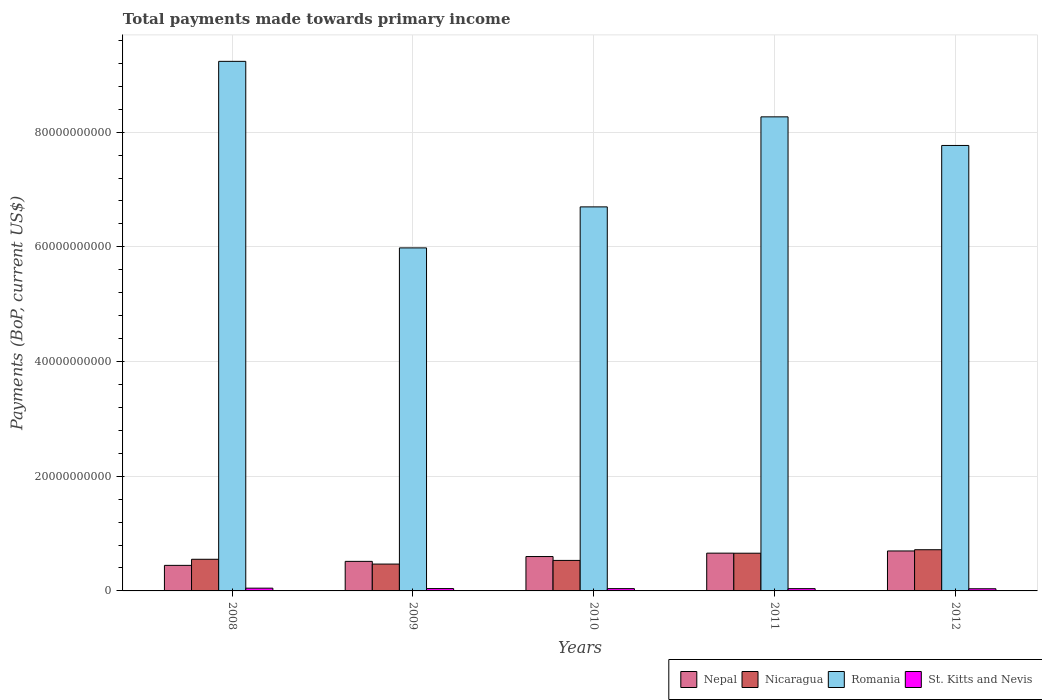How many groups of bars are there?
Your response must be concise. 5. Are the number of bars per tick equal to the number of legend labels?
Your response must be concise. Yes. Are the number of bars on each tick of the X-axis equal?
Make the answer very short. Yes. How many bars are there on the 2nd tick from the left?
Your response must be concise. 4. What is the label of the 2nd group of bars from the left?
Ensure brevity in your answer.  2009. What is the total payments made towards primary income in Nepal in 2008?
Your response must be concise. 4.46e+09. Across all years, what is the maximum total payments made towards primary income in St. Kitts and Nevis?
Make the answer very short. 4.81e+08. Across all years, what is the minimum total payments made towards primary income in Nicaragua?
Make the answer very short. 4.68e+09. In which year was the total payments made towards primary income in Nicaragua minimum?
Your answer should be very brief. 2009. What is the total total payments made towards primary income in Nepal in the graph?
Ensure brevity in your answer.  2.92e+1. What is the difference between the total payments made towards primary income in St. Kitts and Nevis in 2008 and that in 2009?
Provide a succinct answer. 7.06e+07. What is the difference between the total payments made towards primary income in Nicaragua in 2010 and the total payments made towards primary income in Nepal in 2009?
Provide a short and direct response. 1.66e+08. What is the average total payments made towards primary income in Nicaragua per year?
Offer a terse response. 5.86e+09. In the year 2009, what is the difference between the total payments made towards primary income in St. Kitts and Nevis and total payments made towards primary income in Romania?
Offer a terse response. -5.94e+1. In how many years, is the total payments made towards primary income in Nicaragua greater than 60000000000 US$?
Provide a short and direct response. 0. What is the ratio of the total payments made towards primary income in Romania in 2008 to that in 2011?
Ensure brevity in your answer.  1.12. What is the difference between the highest and the second highest total payments made towards primary income in Nicaragua?
Keep it short and to the point. 6.07e+08. What is the difference between the highest and the lowest total payments made towards primary income in Nepal?
Provide a short and direct response. 2.51e+09. Is it the case that in every year, the sum of the total payments made towards primary income in Romania and total payments made towards primary income in St. Kitts and Nevis is greater than the sum of total payments made towards primary income in Nepal and total payments made towards primary income in Nicaragua?
Keep it short and to the point. No. What does the 2nd bar from the left in 2008 represents?
Ensure brevity in your answer.  Nicaragua. What does the 1st bar from the right in 2010 represents?
Your answer should be very brief. St. Kitts and Nevis. How many years are there in the graph?
Provide a short and direct response. 5. What is the difference between two consecutive major ticks on the Y-axis?
Offer a very short reply. 2.00e+1. Does the graph contain any zero values?
Keep it short and to the point. No. Does the graph contain grids?
Your answer should be very brief. Yes. Where does the legend appear in the graph?
Your answer should be compact. Bottom right. How many legend labels are there?
Offer a very short reply. 4. How are the legend labels stacked?
Ensure brevity in your answer.  Horizontal. What is the title of the graph?
Ensure brevity in your answer.  Total payments made towards primary income. What is the label or title of the X-axis?
Provide a succinct answer. Years. What is the label or title of the Y-axis?
Your response must be concise. Payments (BoP, current US$). What is the Payments (BoP, current US$) of Nepal in 2008?
Keep it short and to the point. 4.46e+09. What is the Payments (BoP, current US$) in Nicaragua in 2008?
Ensure brevity in your answer.  5.52e+09. What is the Payments (BoP, current US$) of Romania in 2008?
Your response must be concise. 9.23e+1. What is the Payments (BoP, current US$) in St. Kitts and Nevis in 2008?
Your answer should be compact. 4.81e+08. What is the Payments (BoP, current US$) of Nepal in 2009?
Your answer should be very brief. 5.15e+09. What is the Payments (BoP, current US$) in Nicaragua in 2009?
Make the answer very short. 4.68e+09. What is the Payments (BoP, current US$) of Romania in 2009?
Your response must be concise. 5.98e+1. What is the Payments (BoP, current US$) in St. Kitts and Nevis in 2009?
Give a very brief answer. 4.11e+08. What is the Payments (BoP, current US$) in Nepal in 2010?
Your answer should be compact. 5.99e+09. What is the Payments (BoP, current US$) in Nicaragua in 2010?
Keep it short and to the point. 5.32e+09. What is the Payments (BoP, current US$) of Romania in 2010?
Your answer should be compact. 6.70e+1. What is the Payments (BoP, current US$) in St. Kitts and Nevis in 2010?
Your answer should be very brief. 4.01e+08. What is the Payments (BoP, current US$) of Nepal in 2011?
Keep it short and to the point. 6.59e+09. What is the Payments (BoP, current US$) in Nicaragua in 2011?
Ensure brevity in your answer.  6.58e+09. What is the Payments (BoP, current US$) of Romania in 2011?
Your response must be concise. 8.27e+1. What is the Payments (BoP, current US$) in St. Kitts and Nevis in 2011?
Offer a terse response. 3.98e+08. What is the Payments (BoP, current US$) in Nepal in 2012?
Your response must be concise. 6.97e+09. What is the Payments (BoP, current US$) of Nicaragua in 2012?
Provide a short and direct response. 7.18e+09. What is the Payments (BoP, current US$) in Romania in 2012?
Provide a short and direct response. 7.77e+1. What is the Payments (BoP, current US$) in St. Kitts and Nevis in 2012?
Provide a succinct answer. 3.76e+08. Across all years, what is the maximum Payments (BoP, current US$) in Nepal?
Your answer should be compact. 6.97e+09. Across all years, what is the maximum Payments (BoP, current US$) of Nicaragua?
Your response must be concise. 7.18e+09. Across all years, what is the maximum Payments (BoP, current US$) in Romania?
Offer a very short reply. 9.23e+1. Across all years, what is the maximum Payments (BoP, current US$) of St. Kitts and Nevis?
Ensure brevity in your answer.  4.81e+08. Across all years, what is the minimum Payments (BoP, current US$) of Nepal?
Keep it short and to the point. 4.46e+09. Across all years, what is the minimum Payments (BoP, current US$) in Nicaragua?
Make the answer very short. 4.68e+09. Across all years, what is the minimum Payments (BoP, current US$) in Romania?
Your answer should be very brief. 5.98e+1. Across all years, what is the minimum Payments (BoP, current US$) in St. Kitts and Nevis?
Provide a succinct answer. 3.76e+08. What is the total Payments (BoP, current US$) in Nepal in the graph?
Ensure brevity in your answer.  2.92e+1. What is the total Payments (BoP, current US$) in Nicaragua in the graph?
Provide a succinct answer. 2.93e+1. What is the total Payments (BoP, current US$) of Romania in the graph?
Make the answer very short. 3.79e+11. What is the total Payments (BoP, current US$) in St. Kitts and Nevis in the graph?
Offer a very short reply. 2.07e+09. What is the difference between the Payments (BoP, current US$) in Nepal in 2008 and that in 2009?
Your answer should be compact. -6.98e+08. What is the difference between the Payments (BoP, current US$) in Nicaragua in 2008 and that in 2009?
Provide a short and direct response. 8.38e+08. What is the difference between the Payments (BoP, current US$) in Romania in 2008 and that in 2009?
Keep it short and to the point. 3.25e+1. What is the difference between the Payments (BoP, current US$) of St. Kitts and Nevis in 2008 and that in 2009?
Offer a very short reply. 7.06e+07. What is the difference between the Payments (BoP, current US$) in Nepal in 2008 and that in 2010?
Your answer should be compact. -1.54e+09. What is the difference between the Payments (BoP, current US$) of Nicaragua in 2008 and that in 2010?
Your answer should be very brief. 2.00e+08. What is the difference between the Payments (BoP, current US$) of Romania in 2008 and that in 2010?
Ensure brevity in your answer.  2.54e+1. What is the difference between the Payments (BoP, current US$) of St. Kitts and Nevis in 2008 and that in 2010?
Give a very brief answer. 8.02e+07. What is the difference between the Payments (BoP, current US$) of Nepal in 2008 and that in 2011?
Your answer should be compact. -2.13e+09. What is the difference between the Payments (BoP, current US$) of Nicaragua in 2008 and that in 2011?
Ensure brevity in your answer.  -1.06e+09. What is the difference between the Payments (BoP, current US$) in Romania in 2008 and that in 2011?
Offer a very short reply. 9.68e+09. What is the difference between the Payments (BoP, current US$) of St. Kitts and Nevis in 2008 and that in 2011?
Give a very brief answer. 8.34e+07. What is the difference between the Payments (BoP, current US$) in Nepal in 2008 and that in 2012?
Offer a very short reply. -2.51e+09. What is the difference between the Payments (BoP, current US$) in Nicaragua in 2008 and that in 2012?
Make the answer very short. -1.66e+09. What is the difference between the Payments (BoP, current US$) of Romania in 2008 and that in 2012?
Ensure brevity in your answer.  1.47e+1. What is the difference between the Payments (BoP, current US$) of St. Kitts and Nevis in 2008 and that in 2012?
Ensure brevity in your answer.  1.05e+08. What is the difference between the Payments (BoP, current US$) in Nepal in 2009 and that in 2010?
Your response must be concise. -8.42e+08. What is the difference between the Payments (BoP, current US$) in Nicaragua in 2009 and that in 2010?
Provide a short and direct response. -6.38e+08. What is the difference between the Payments (BoP, current US$) of Romania in 2009 and that in 2010?
Make the answer very short. -7.15e+09. What is the difference between the Payments (BoP, current US$) in St. Kitts and Nevis in 2009 and that in 2010?
Offer a terse response. 9.59e+06. What is the difference between the Payments (BoP, current US$) of Nepal in 2009 and that in 2011?
Your answer should be compact. -1.43e+09. What is the difference between the Payments (BoP, current US$) in Nicaragua in 2009 and that in 2011?
Keep it short and to the point. -1.90e+09. What is the difference between the Payments (BoP, current US$) of Romania in 2009 and that in 2011?
Provide a short and direct response. -2.29e+1. What is the difference between the Payments (BoP, current US$) of St. Kitts and Nevis in 2009 and that in 2011?
Your answer should be very brief. 1.28e+07. What is the difference between the Payments (BoP, current US$) in Nepal in 2009 and that in 2012?
Ensure brevity in your answer.  -1.82e+09. What is the difference between the Payments (BoP, current US$) of Nicaragua in 2009 and that in 2012?
Your answer should be very brief. -2.50e+09. What is the difference between the Payments (BoP, current US$) of Romania in 2009 and that in 2012?
Offer a very short reply. -1.79e+1. What is the difference between the Payments (BoP, current US$) of St. Kitts and Nevis in 2009 and that in 2012?
Offer a very short reply. 3.41e+07. What is the difference between the Payments (BoP, current US$) in Nepal in 2010 and that in 2011?
Offer a terse response. -5.93e+08. What is the difference between the Payments (BoP, current US$) in Nicaragua in 2010 and that in 2011?
Give a very brief answer. -1.26e+09. What is the difference between the Payments (BoP, current US$) in Romania in 2010 and that in 2011?
Your answer should be very brief. -1.57e+1. What is the difference between the Payments (BoP, current US$) of St. Kitts and Nevis in 2010 and that in 2011?
Provide a succinct answer. 3.21e+06. What is the difference between the Payments (BoP, current US$) in Nepal in 2010 and that in 2012?
Offer a terse response. -9.74e+08. What is the difference between the Payments (BoP, current US$) in Nicaragua in 2010 and that in 2012?
Ensure brevity in your answer.  -1.86e+09. What is the difference between the Payments (BoP, current US$) in Romania in 2010 and that in 2012?
Make the answer very short. -1.07e+1. What is the difference between the Payments (BoP, current US$) of St. Kitts and Nevis in 2010 and that in 2012?
Give a very brief answer. 2.45e+07. What is the difference between the Payments (BoP, current US$) of Nepal in 2011 and that in 2012?
Offer a terse response. -3.82e+08. What is the difference between the Payments (BoP, current US$) in Nicaragua in 2011 and that in 2012?
Offer a very short reply. -6.07e+08. What is the difference between the Payments (BoP, current US$) of Romania in 2011 and that in 2012?
Provide a short and direct response. 4.99e+09. What is the difference between the Payments (BoP, current US$) in St. Kitts and Nevis in 2011 and that in 2012?
Keep it short and to the point. 2.13e+07. What is the difference between the Payments (BoP, current US$) in Nepal in 2008 and the Payments (BoP, current US$) in Nicaragua in 2009?
Keep it short and to the point. -2.25e+08. What is the difference between the Payments (BoP, current US$) in Nepal in 2008 and the Payments (BoP, current US$) in Romania in 2009?
Your answer should be very brief. -5.54e+1. What is the difference between the Payments (BoP, current US$) of Nepal in 2008 and the Payments (BoP, current US$) of St. Kitts and Nevis in 2009?
Your answer should be compact. 4.05e+09. What is the difference between the Payments (BoP, current US$) in Nicaragua in 2008 and the Payments (BoP, current US$) in Romania in 2009?
Offer a terse response. -5.43e+1. What is the difference between the Payments (BoP, current US$) in Nicaragua in 2008 and the Payments (BoP, current US$) in St. Kitts and Nevis in 2009?
Provide a succinct answer. 5.11e+09. What is the difference between the Payments (BoP, current US$) in Romania in 2008 and the Payments (BoP, current US$) in St. Kitts and Nevis in 2009?
Give a very brief answer. 9.19e+1. What is the difference between the Payments (BoP, current US$) in Nepal in 2008 and the Payments (BoP, current US$) in Nicaragua in 2010?
Ensure brevity in your answer.  -8.64e+08. What is the difference between the Payments (BoP, current US$) of Nepal in 2008 and the Payments (BoP, current US$) of Romania in 2010?
Your answer should be compact. -6.25e+1. What is the difference between the Payments (BoP, current US$) of Nepal in 2008 and the Payments (BoP, current US$) of St. Kitts and Nevis in 2010?
Provide a short and direct response. 4.05e+09. What is the difference between the Payments (BoP, current US$) of Nicaragua in 2008 and the Payments (BoP, current US$) of Romania in 2010?
Your answer should be compact. -6.14e+1. What is the difference between the Payments (BoP, current US$) of Nicaragua in 2008 and the Payments (BoP, current US$) of St. Kitts and Nevis in 2010?
Your response must be concise. 5.12e+09. What is the difference between the Payments (BoP, current US$) in Romania in 2008 and the Payments (BoP, current US$) in St. Kitts and Nevis in 2010?
Provide a succinct answer. 9.19e+1. What is the difference between the Payments (BoP, current US$) of Nepal in 2008 and the Payments (BoP, current US$) of Nicaragua in 2011?
Offer a very short reply. -2.12e+09. What is the difference between the Payments (BoP, current US$) of Nepal in 2008 and the Payments (BoP, current US$) of Romania in 2011?
Your answer should be compact. -7.82e+1. What is the difference between the Payments (BoP, current US$) in Nepal in 2008 and the Payments (BoP, current US$) in St. Kitts and Nevis in 2011?
Offer a terse response. 4.06e+09. What is the difference between the Payments (BoP, current US$) of Nicaragua in 2008 and the Payments (BoP, current US$) of Romania in 2011?
Your response must be concise. -7.71e+1. What is the difference between the Payments (BoP, current US$) in Nicaragua in 2008 and the Payments (BoP, current US$) in St. Kitts and Nevis in 2011?
Make the answer very short. 5.12e+09. What is the difference between the Payments (BoP, current US$) of Romania in 2008 and the Payments (BoP, current US$) of St. Kitts and Nevis in 2011?
Your answer should be compact. 9.19e+1. What is the difference between the Payments (BoP, current US$) of Nepal in 2008 and the Payments (BoP, current US$) of Nicaragua in 2012?
Your response must be concise. -2.73e+09. What is the difference between the Payments (BoP, current US$) of Nepal in 2008 and the Payments (BoP, current US$) of Romania in 2012?
Provide a short and direct response. -7.32e+1. What is the difference between the Payments (BoP, current US$) in Nepal in 2008 and the Payments (BoP, current US$) in St. Kitts and Nevis in 2012?
Your answer should be very brief. 4.08e+09. What is the difference between the Payments (BoP, current US$) in Nicaragua in 2008 and the Payments (BoP, current US$) in Romania in 2012?
Offer a very short reply. -7.22e+1. What is the difference between the Payments (BoP, current US$) of Nicaragua in 2008 and the Payments (BoP, current US$) of St. Kitts and Nevis in 2012?
Provide a short and direct response. 5.14e+09. What is the difference between the Payments (BoP, current US$) in Romania in 2008 and the Payments (BoP, current US$) in St. Kitts and Nevis in 2012?
Give a very brief answer. 9.20e+1. What is the difference between the Payments (BoP, current US$) in Nepal in 2009 and the Payments (BoP, current US$) in Nicaragua in 2010?
Give a very brief answer. -1.66e+08. What is the difference between the Payments (BoP, current US$) in Nepal in 2009 and the Payments (BoP, current US$) in Romania in 2010?
Your response must be concise. -6.18e+1. What is the difference between the Payments (BoP, current US$) of Nepal in 2009 and the Payments (BoP, current US$) of St. Kitts and Nevis in 2010?
Provide a succinct answer. 4.75e+09. What is the difference between the Payments (BoP, current US$) of Nicaragua in 2009 and the Payments (BoP, current US$) of Romania in 2010?
Offer a terse response. -6.23e+1. What is the difference between the Payments (BoP, current US$) in Nicaragua in 2009 and the Payments (BoP, current US$) in St. Kitts and Nevis in 2010?
Your answer should be very brief. 4.28e+09. What is the difference between the Payments (BoP, current US$) of Romania in 2009 and the Payments (BoP, current US$) of St. Kitts and Nevis in 2010?
Provide a succinct answer. 5.94e+1. What is the difference between the Payments (BoP, current US$) in Nepal in 2009 and the Payments (BoP, current US$) in Nicaragua in 2011?
Ensure brevity in your answer.  -1.42e+09. What is the difference between the Payments (BoP, current US$) of Nepal in 2009 and the Payments (BoP, current US$) of Romania in 2011?
Your response must be concise. -7.75e+1. What is the difference between the Payments (BoP, current US$) in Nepal in 2009 and the Payments (BoP, current US$) in St. Kitts and Nevis in 2011?
Your response must be concise. 4.76e+09. What is the difference between the Payments (BoP, current US$) in Nicaragua in 2009 and the Payments (BoP, current US$) in Romania in 2011?
Your answer should be compact. -7.80e+1. What is the difference between the Payments (BoP, current US$) of Nicaragua in 2009 and the Payments (BoP, current US$) of St. Kitts and Nevis in 2011?
Offer a terse response. 4.28e+09. What is the difference between the Payments (BoP, current US$) of Romania in 2009 and the Payments (BoP, current US$) of St. Kitts and Nevis in 2011?
Make the answer very short. 5.94e+1. What is the difference between the Payments (BoP, current US$) in Nepal in 2009 and the Payments (BoP, current US$) in Nicaragua in 2012?
Keep it short and to the point. -2.03e+09. What is the difference between the Payments (BoP, current US$) of Nepal in 2009 and the Payments (BoP, current US$) of Romania in 2012?
Make the answer very short. -7.25e+1. What is the difference between the Payments (BoP, current US$) of Nepal in 2009 and the Payments (BoP, current US$) of St. Kitts and Nevis in 2012?
Give a very brief answer. 4.78e+09. What is the difference between the Payments (BoP, current US$) in Nicaragua in 2009 and the Payments (BoP, current US$) in Romania in 2012?
Provide a succinct answer. -7.30e+1. What is the difference between the Payments (BoP, current US$) in Nicaragua in 2009 and the Payments (BoP, current US$) in St. Kitts and Nevis in 2012?
Give a very brief answer. 4.30e+09. What is the difference between the Payments (BoP, current US$) of Romania in 2009 and the Payments (BoP, current US$) of St. Kitts and Nevis in 2012?
Make the answer very short. 5.94e+1. What is the difference between the Payments (BoP, current US$) in Nepal in 2010 and the Payments (BoP, current US$) in Nicaragua in 2011?
Offer a terse response. -5.81e+08. What is the difference between the Payments (BoP, current US$) of Nepal in 2010 and the Payments (BoP, current US$) of Romania in 2011?
Offer a very short reply. -7.67e+1. What is the difference between the Payments (BoP, current US$) in Nepal in 2010 and the Payments (BoP, current US$) in St. Kitts and Nevis in 2011?
Ensure brevity in your answer.  5.60e+09. What is the difference between the Payments (BoP, current US$) in Nicaragua in 2010 and the Payments (BoP, current US$) in Romania in 2011?
Make the answer very short. -7.73e+1. What is the difference between the Payments (BoP, current US$) in Nicaragua in 2010 and the Payments (BoP, current US$) in St. Kitts and Nevis in 2011?
Your answer should be very brief. 4.92e+09. What is the difference between the Payments (BoP, current US$) of Romania in 2010 and the Payments (BoP, current US$) of St. Kitts and Nevis in 2011?
Provide a succinct answer. 6.66e+1. What is the difference between the Payments (BoP, current US$) of Nepal in 2010 and the Payments (BoP, current US$) of Nicaragua in 2012?
Offer a terse response. -1.19e+09. What is the difference between the Payments (BoP, current US$) in Nepal in 2010 and the Payments (BoP, current US$) in Romania in 2012?
Give a very brief answer. -7.17e+1. What is the difference between the Payments (BoP, current US$) in Nepal in 2010 and the Payments (BoP, current US$) in St. Kitts and Nevis in 2012?
Make the answer very short. 5.62e+09. What is the difference between the Payments (BoP, current US$) in Nicaragua in 2010 and the Payments (BoP, current US$) in Romania in 2012?
Offer a very short reply. -7.24e+1. What is the difference between the Payments (BoP, current US$) in Nicaragua in 2010 and the Payments (BoP, current US$) in St. Kitts and Nevis in 2012?
Offer a very short reply. 4.94e+09. What is the difference between the Payments (BoP, current US$) in Romania in 2010 and the Payments (BoP, current US$) in St. Kitts and Nevis in 2012?
Keep it short and to the point. 6.66e+1. What is the difference between the Payments (BoP, current US$) in Nepal in 2011 and the Payments (BoP, current US$) in Nicaragua in 2012?
Offer a very short reply. -5.95e+08. What is the difference between the Payments (BoP, current US$) of Nepal in 2011 and the Payments (BoP, current US$) of Romania in 2012?
Offer a very short reply. -7.11e+1. What is the difference between the Payments (BoP, current US$) of Nepal in 2011 and the Payments (BoP, current US$) of St. Kitts and Nevis in 2012?
Offer a terse response. 6.21e+09. What is the difference between the Payments (BoP, current US$) in Nicaragua in 2011 and the Payments (BoP, current US$) in Romania in 2012?
Offer a very short reply. -7.11e+1. What is the difference between the Payments (BoP, current US$) of Nicaragua in 2011 and the Payments (BoP, current US$) of St. Kitts and Nevis in 2012?
Provide a succinct answer. 6.20e+09. What is the difference between the Payments (BoP, current US$) of Romania in 2011 and the Payments (BoP, current US$) of St. Kitts and Nevis in 2012?
Offer a very short reply. 8.23e+1. What is the average Payments (BoP, current US$) in Nepal per year?
Your answer should be compact. 5.83e+09. What is the average Payments (BoP, current US$) of Nicaragua per year?
Your answer should be compact. 5.86e+09. What is the average Payments (BoP, current US$) in Romania per year?
Offer a terse response. 7.59e+1. What is the average Payments (BoP, current US$) in St. Kitts and Nevis per year?
Provide a short and direct response. 4.13e+08. In the year 2008, what is the difference between the Payments (BoP, current US$) of Nepal and Payments (BoP, current US$) of Nicaragua?
Ensure brevity in your answer.  -1.06e+09. In the year 2008, what is the difference between the Payments (BoP, current US$) of Nepal and Payments (BoP, current US$) of Romania?
Offer a very short reply. -8.79e+1. In the year 2008, what is the difference between the Payments (BoP, current US$) of Nepal and Payments (BoP, current US$) of St. Kitts and Nevis?
Provide a short and direct response. 3.97e+09. In the year 2008, what is the difference between the Payments (BoP, current US$) of Nicaragua and Payments (BoP, current US$) of Romania?
Ensure brevity in your answer.  -8.68e+1. In the year 2008, what is the difference between the Payments (BoP, current US$) in Nicaragua and Payments (BoP, current US$) in St. Kitts and Nevis?
Ensure brevity in your answer.  5.04e+09. In the year 2008, what is the difference between the Payments (BoP, current US$) of Romania and Payments (BoP, current US$) of St. Kitts and Nevis?
Give a very brief answer. 9.19e+1. In the year 2009, what is the difference between the Payments (BoP, current US$) of Nepal and Payments (BoP, current US$) of Nicaragua?
Your response must be concise. 4.72e+08. In the year 2009, what is the difference between the Payments (BoP, current US$) of Nepal and Payments (BoP, current US$) of Romania?
Provide a succinct answer. -5.47e+1. In the year 2009, what is the difference between the Payments (BoP, current US$) of Nepal and Payments (BoP, current US$) of St. Kitts and Nevis?
Your answer should be compact. 4.74e+09. In the year 2009, what is the difference between the Payments (BoP, current US$) of Nicaragua and Payments (BoP, current US$) of Romania?
Provide a short and direct response. -5.51e+1. In the year 2009, what is the difference between the Payments (BoP, current US$) of Nicaragua and Payments (BoP, current US$) of St. Kitts and Nevis?
Provide a succinct answer. 4.27e+09. In the year 2009, what is the difference between the Payments (BoP, current US$) of Romania and Payments (BoP, current US$) of St. Kitts and Nevis?
Keep it short and to the point. 5.94e+1. In the year 2010, what is the difference between the Payments (BoP, current US$) of Nepal and Payments (BoP, current US$) of Nicaragua?
Ensure brevity in your answer.  6.76e+08. In the year 2010, what is the difference between the Payments (BoP, current US$) of Nepal and Payments (BoP, current US$) of Romania?
Offer a terse response. -6.10e+1. In the year 2010, what is the difference between the Payments (BoP, current US$) of Nepal and Payments (BoP, current US$) of St. Kitts and Nevis?
Your answer should be compact. 5.59e+09. In the year 2010, what is the difference between the Payments (BoP, current US$) in Nicaragua and Payments (BoP, current US$) in Romania?
Your answer should be compact. -6.16e+1. In the year 2010, what is the difference between the Payments (BoP, current US$) in Nicaragua and Payments (BoP, current US$) in St. Kitts and Nevis?
Provide a short and direct response. 4.92e+09. In the year 2010, what is the difference between the Payments (BoP, current US$) in Romania and Payments (BoP, current US$) in St. Kitts and Nevis?
Keep it short and to the point. 6.66e+1. In the year 2011, what is the difference between the Payments (BoP, current US$) of Nepal and Payments (BoP, current US$) of Nicaragua?
Make the answer very short. 1.15e+07. In the year 2011, what is the difference between the Payments (BoP, current US$) of Nepal and Payments (BoP, current US$) of Romania?
Your answer should be compact. -7.61e+1. In the year 2011, what is the difference between the Payments (BoP, current US$) of Nepal and Payments (BoP, current US$) of St. Kitts and Nevis?
Your response must be concise. 6.19e+09. In the year 2011, what is the difference between the Payments (BoP, current US$) of Nicaragua and Payments (BoP, current US$) of Romania?
Ensure brevity in your answer.  -7.61e+1. In the year 2011, what is the difference between the Payments (BoP, current US$) of Nicaragua and Payments (BoP, current US$) of St. Kitts and Nevis?
Keep it short and to the point. 6.18e+09. In the year 2011, what is the difference between the Payments (BoP, current US$) of Romania and Payments (BoP, current US$) of St. Kitts and Nevis?
Offer a very short reply. 8.23e+1. In the year 2012, what is the difference between the Payments (BoP, current US$) in Nepal and Payments (BoP, current US$) in Nicaragua?
Offer a terse response. -2.13e+08. In the year 2012, what is the difference between the Payments (BoP, current US$) in Nepal and Payments (BoP, current US$) in Romania?
Your answer should be compact. -7.07e+1. In the year 2012, what is the difference between the Payments (BoP, current US$) of Nepal and Payments (BoP, current US$) of St. Kitts and Nevis?
Your answer should be compact. 6.59e+09. In the year 2012, what is the difference between the Payments (BoP, current US$) of Nicaragua and Payments (BoP, current US$) of Romania?
Keep it short and to the point. -7.05e+1. In the year 2012, what is the difference between the Payments (BoP, current US$) of Nicaragua and Payments (BoP, current US$) of St. Kitts and Nevis?
Keep it short and to the point. 6.81e+09. In the year 2012, what is the difference between the Payments (BoP, current US$) of Romania and Payments (BoP, current US$) of St. Kitts and Nevis?
Offer a very short reply. 7.73e+1. What is the ratio of the Payments (BoP, current US$) in Nepal in 2008 to that in 2009?
Provide a succinct answer. 0.86. What is the ratio of the Payments (BoP, current US$) of Nicaragua in 2008 to that in 2009?
Your answer should be compact. 1.18. What is the ratio of the Payments (BoP, current US$) of Romania in 2008 to that in 2009?
Your response must be concise. 1.54. What is the ratio of the Payments (BoP, current US$) of St. Kitts and Nevis in 2008 to that in 2009?
Give a very brief answer. 1.17. What is the ratio of the Payments (BoP, current US$) in Nepal in 2008 to that in 2010?
Your answer should be very brief. 0.74. What is the ratio of the Payments (BoP, current US$) of Nicaragua in 2008 to that in 2010?
Ensure brevity in your answer.  1.04. What is the ratio of the Payments (BoP, current US$) of Romania in 2008 to that in 2010?
Make the answer very short. 1.38. What is the ratio of the Payments (BoP, current US$) of St. Kitts and Nevis in 2008 to that in 2010?
Offer a terse response. 1.2. What is the ratio of the Payments (BoP, current US$) in Nepal in 2008 to that in 2011?
Offer a terse response. 0.68. What is the ratio of the Payments (BoP, current US$) in Nicaragua in 2008 to that in 2011?
Provide a succinct answer. 0.84. What is the ratio of the Payments (BoP, current US$) of Romania in 2008 to that in 2011?
Your answer should be very brief. 1.12. What is the ratio of the Payments (BoP, current US$) of St. Kitts and Nevis in 2008 to that in 2011?
Offer a terse response. 1.21. What is the ratio of the Payments (BoP, current US$) in Nepal in 2008 to that in 2012?
Keep it short and to the point. 0.64. What is the ratio of the Payments (BoP, current US$) of Nicaragua in 2008 to that in 2012?
Provide a succinct answer. 0.77. What is the ratio of the Payments (BoP, current US$) in Romania in 2008 to that in 2012?
Offer a very short reply. 1.19. What is the ratio of the Payments (BoP, current US$) of St. Kitts and Nevis in 2008 to that in 2012?
Make the answer very short. 1.28. What is the ratio of the Payments (BoP, current US$) in Nepal in 2009 to that in 2010?
Offer a terse response. 0.86. What is the ratio of the Payments (BoP, current US$) in Nicaragua in 2009 to that in 2010?
Provide a short and direct response. 0.88. What is the ratio of the Payments (BoP, current US$) of Romania in 2009 to that in 2010?
Offer a very short reply. 0.89. What is the ratio of the Payments (BoP, current US$) of St. Kitts and Nevis in 2009 to that in 2010?
Your answer should be very brief. 1.02. What is the ratio of the Payments (BoP, current US$) of Nepal in 2009 to that in 2011?
Make the answer very short. 0.78. What is the ratio of the Payments (BoP, current US$) of Nicaragua in 2009 to that in 2011?
Give a very brief answer. 0.71. What is the ratio of the Payments (BoP, current US$) of Romania in 2009 to that in 2011?
Make the answer very short. 0.72. What is the ratio of the Payments (BoP, current US$) of St. Kitts and Nevis in 2009 to that in 2011?
Offer a very short reply. 1.03. What is the ratio of the Payments (BoP, current US$) of Nepal in 2009 to that in 2012?
Ensure brevity in your answer.  0.74. What is the ratio of the Payments (BoP, current US$) of Nicaragua in 2009 to that in 2012?
Your answer should be compact. 0.65. What is the ratio of the Payments (BoP, current US$) of Romania in 2009 to that in 2012?
Provide a succinct answer. 0.77. What is the ratio of the Payments (BoP, current US$) in St. Kitts and Nevis in 2009 to that in 2012?
Offer a very short reply. 1.09. What is the ratio of the Payments (BoP, current US$) in Nepal in 2010 to that in 2011?
Ensure brevity in your answer.  0.91. What is the ratio of the Payments (BoP, current US$) in Nicaragua in 2010 to that in 2011?
Give a very brief answer. 0.81. What is the ratio of the Payments (BoP, current US$) in Romania in 2010 to that in 2011?
Your answer should be compact. 0.81. What is the ratio of the Payments (BoP, current US$) of Nepal in 2010 to that in 2012?
Your response must be concise. 0.86. What is the ratio of the Payments (BoP, current US$) of Nicaragua in 2010 to that in 2012?
Your answer should be compact. 0.74. What is the ratio of the Payments (BoP, current US$) in Romania in 2010 to that in 2012?
Ensure brevity in your answer.  0.86. What is the ratio of the Payments (BoP, current US$) of St. Kitts and Nevis in 2010 to that in 2012?
Give a very brief answer. 1.07. What is the ratio of the Payments (BoP, current US$) of Nepal in 2011 to that in 2012?
Your response must be concise. 0.95. What is the ratio of the Payments (BoP, current US$) in Nicaragua in 2011 to that in 2012?
Ensure brevity in your answer.  0.92. What is the ratio of the Payments (BoP, current US$) of Romania in 2011 to that in 2012?
Provide a short and direct response. 1.06. What is the ratio of the Payments (BoP, current US$) of St. Kitts and Nevis in 2011 to that in 2012?
Offer a terse response. 1.06. What is the difference between the highest and the second highest Payments (BoP, current US$) in Nepal?
Make the answer very short. 3.82e+08. What is the difference between the highest and the second highest Payments (BoP, current US$) of Nicaragua?
Keep it short and to the point. 6.07e+08. What is the difference between the highest and the second highest Payments (BoP, current US$) in Romania?
Offer a terse response. 9.68e+09. What is the difference between the highest and the second highest Payments (BoP, current US$) in St. Kitts and Nevis?
Offer a very short reply. 7.06e+07. What is the difference between the highest and the lowest Payments (BoP, current US$) in Nepal?
Offer a terse response. 2.51e+09. What is the difference between the highest and the lowest Payments (BoP, current US$) in Nicaragua?
Make the answer very short. 2.50e+09. What is the difference between the highest and the lowest Payments (BoP, current US$) of Romania?
Your answer should be very brief. 3.25e+1. What is the difference between the highest and the lowest Payments (BoP, current US$) in St. Kitts and Nevis?
Your answer should be compact. 1.05e+08. 